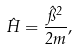<formula> <loc_0><loc_0><loc_500><loc_500>\hat { H } = \frac { \hat { \pi } ^ { 2 } } { 2 m } ,</formula> 